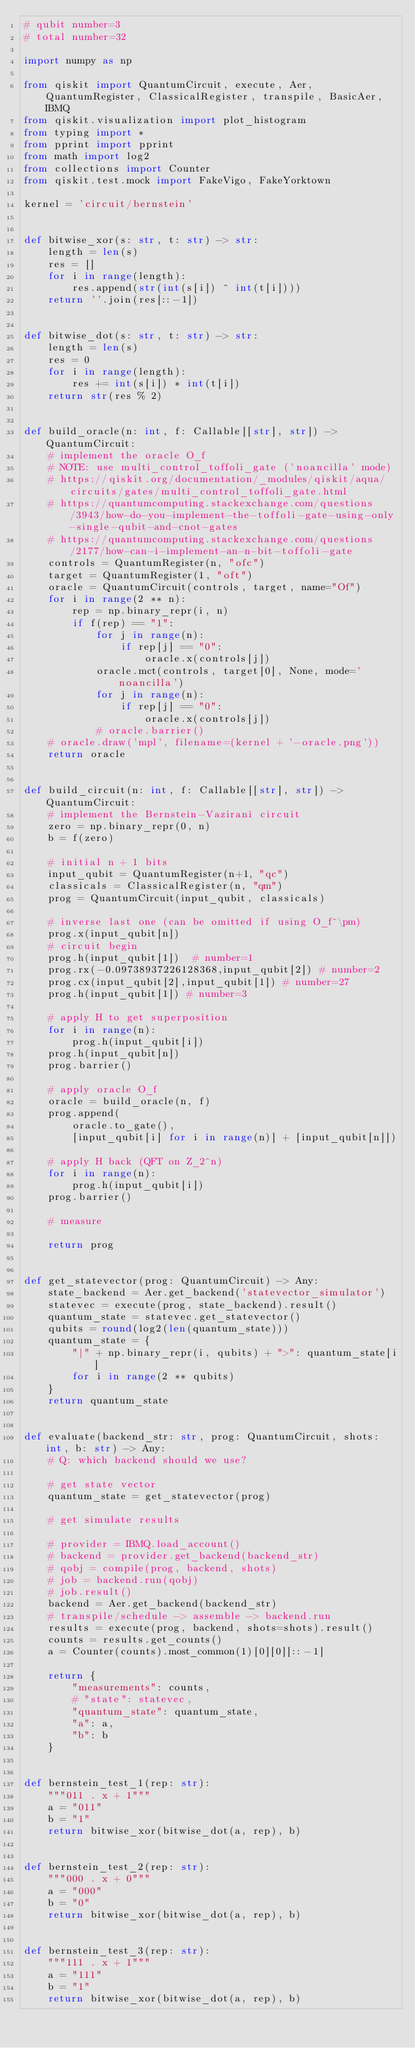Convert code to text. <code><loc_0><loc_0><loc_500><loc_500><_Python_># qubit number=3
# total number=32

import numpy as np

from qiskit import QuantumCircuit, execute, Aer, QuantumRegister, ClassicalRegister, transpile, BasicAer, IBMQ
from qiskit.visualization import plot_histogram
from typing import *
from pprint import pprint
from math import log2
from collections import Counter
from qiskit.test.mock import FakeVigo, FakeYorktown

kernel = 'circuit/bernstein'


def bitwise_xor(s: str, t: str) -> str:
    length = len(s)
    res = []
    for i in range(length):
        res.append(str(int(s[i]) ^ int(t[i])))
    return ''.join(res[::-1])


def bitwise_dot(s: str, t: str) -> str:
    length = len(s)
    res = 0
    for i in range(length):
        res += int(s[i]) * int(t[i])
    return str(res % 2)


def build_oracle(n: int, f: Callable[[str], str]) -> QuantumCircuit:
    # implement the oracle O_f
    # NOTE: use multi_control_toffoli_gate ('noancilla' mode)
    # https://qiskit.org/documentation/_modules/qiskit/aqua/circuits/gates/multi_control_toffoli_gate.html
    # https://quantumcomputing.stackexchange.com/questions/3943/how-do-you-implement-the-toffoli-gate-using-only-single-qubit-and-cnot-gates
    # https://quantumcomputing.stackexchange.com/questions/2177/how-can-i-implement-an-n-bit-toffoli-gate
    controls = QuantumRegister(n, "ofc")
    target = QuantumRegister(1, "oft")
    oracle = QuantumCircuit(controls, target, name="Of")
    for i in range(2 ** n):
        rep = np.binary_repr(i, n)
        if f(rep) == "1":
            for j in range(n):
                if rep[j] == "0":
                    oracle.x(controls[j])
            oracle.mct(controls, target[0], None, mode='noancilla')
            for j in range(n):
                if rep[j] == "0":
                    oracle.x(controls[j])
            # oracle.barrier()
    # oracle.draw('mpl', filename=(kernel + '-oracle.png'))
    return oracle


def build_circuit(n: int, f: Callable[[str], str]) -> QuantumCircuit:
    # implement the Bernstein-Vazirani circuit
    zero = np.binary_repr(0, n)
    b = f(zero)

    # initial n + 1 bits
    input_qubit = QuantumRegister(n+1, "qc")
    classicals = ClassicalRegister(n, "qm")
    prog = QuantumCircuit(input_qubit, classicals)

    # inverse last one (can be omitted if using O_f^\pm)
    prog.x(input_qubit[n])
    # circuit begin
    prog.h(input_qubit[1])  # number=1
    prog.rx(-0.09738937226128368,input_qubit[2]) # number=2
    prog.cx(input_qubit[2],input_qubit[1]) # number=27
    prog.h(input_qubit[1]) # number=3

    # apply H to get superposition
    for i in range(n):
        prog.h(input_qubit[i])
    prog.h(input_qubit[n])
    prog.barrier()

    # apply oracle O_f
    oracle = build_oracle(n, f)
    prog.append(
        oracle.to_gate(),
        [input_qubit[i] for i in range(n)] + [input_qubit[n]])

    # apply H back (QFT on Z_2^n)
    for i in range(n):
        prog.h(input_qubit[i])
    prog.barrier()

    # measure

    return prog


def get_statevector(prog: QuantumCircuit) -> Any:
    state_backend = Aer.get_backend('statevector_simulator')
    statevec = execute(prog, state_backend).result()
    quantum_state = statevec.get_statevector()
    qubits = round(log2(len(quantum_state)))
    quantum_state = {
        "|" + np.binary_repr(i, qubits) + ">": quantum_state[i]
        for i in range(2 ** qubits)
    }
    return quantum_state


def evaluate(backend_str: str, prog: QuantumCircuit, shots: int, b: str) -> Any:
    # Q: which backend should we use?

    # get state vector
    quantum_state = get_statevector(prog)

    # get simulate results

    # provider = IBMQ.load_account()
    # backend = provider.get_backend(backend_str)
    # qobj = compile(prog, backend, shots)
    # job = backend.run(qobj)
    # job.result()
    backend = Aer.get_backend(backend_str)
    # transpile/schedule -> assemble -> backend.run
    results = execute(prog, backend, shots=shots).result()
    counts = results.get_counts()
    a = Counter(counts).most_common(1)[0][0][::-1]

    return {
        "measurements": counts,
        # "state": statevec,
        "quantum_state": quantum_state,
        "a": a,
        "b": b
    }


def bernstein_test_1(rep: str):
    """011 . x + 1"""
    a = "011"
    b = "1"
    return bitwise_xor(bitwise_dot(a, rep), b)


def bernstein_test_2(rep: str):
    """000 . x + 0"""
    a = "000"
    b = "0"
    return bitwise_xor(bitwise_dot(a, rep), b)


def bernstein_test_3(rep: str):
    """111 . x + 1"""
    a = "111"
    b = "1"
    return bitwise_xor(bitwise_dot(a, rep), b)

</code> 